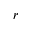<formula> <loc_0><loc_0><loc_500><loc_500>r</formula> 